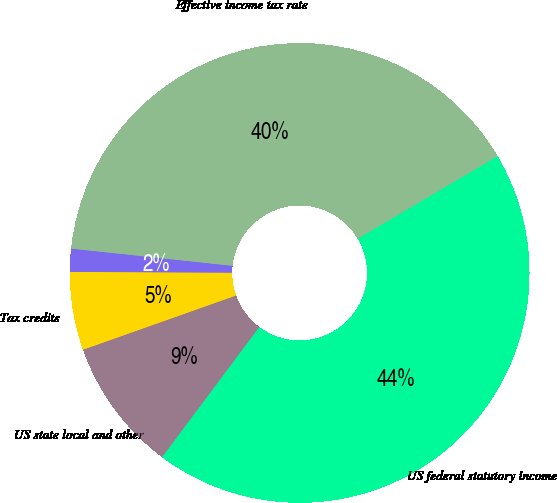<chart> <loc_0><loc_0><loc_500><loc_500><pie_chart><fcel>US federal statutory income<fcel>US state local and other<fcel>Tax credits<fcel>Other<fcel>Effective income tax rate<nl><fcel>43.7%<fcel>9.37%<fcel>5.49%<fcel>1.62%<fcel>39.82%<nl></chart> 